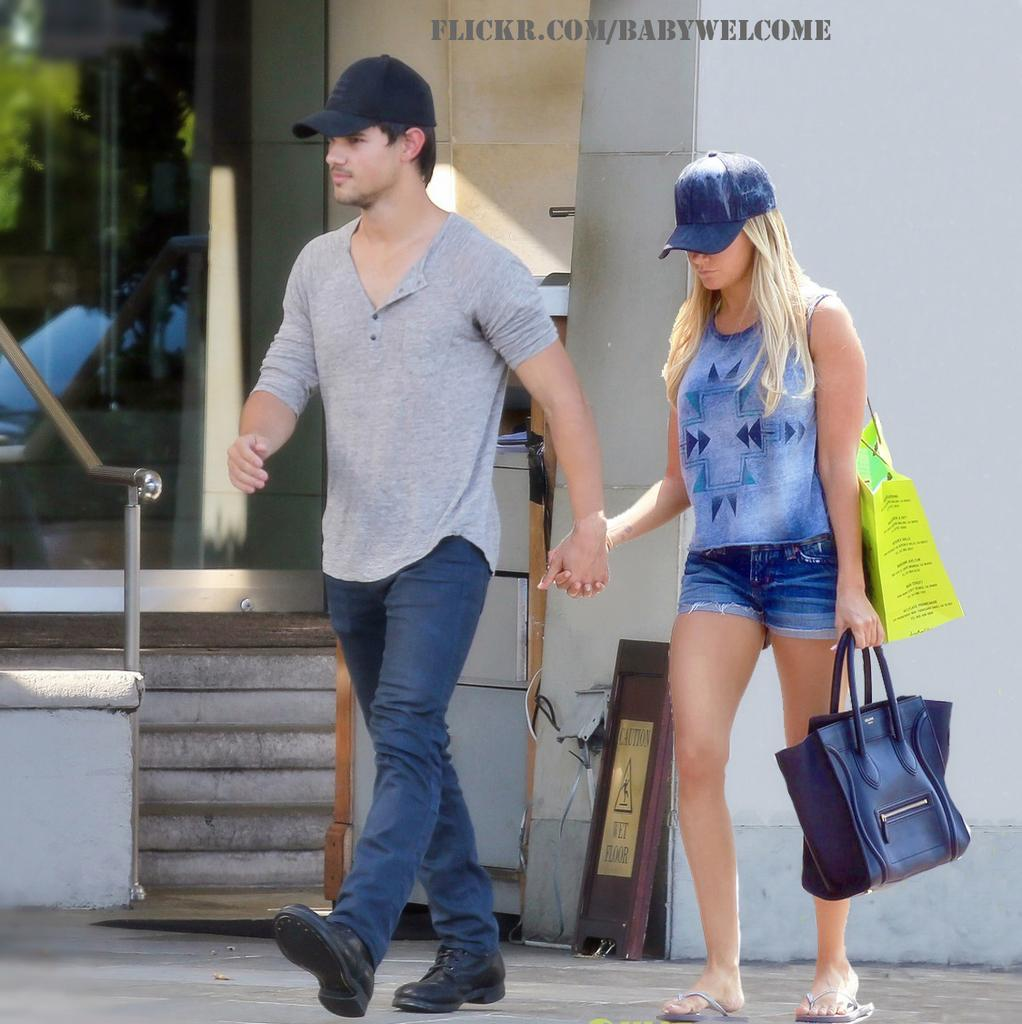How many people are present in the image? There are two persons in the image. What are the two persons doing in the image? The two persons are walking. What can be seen in the background of the image? There is a building in the background of the image. What type of knee injury can be seen on the person's face in the image? There is no knee injury or any injury visible on the person's face in the image. 